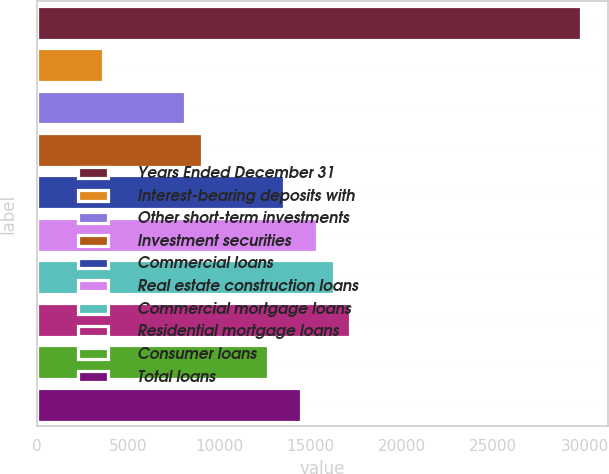Convert chart to OTSL. <chart><loc_0><loc_0><loc_500><loc_500><bar_chart><fcel>Years Ended December 31<fcel>Interest-bearing deposits with<fcel>Other short-term investments<fcel>Investment securities<fcel>Commercial loans<fcel>Real estate construction loans<fcel>Commercial mortgage loans<fcel>Residential mortgage loans<fcel>Consumer loans<fcel>Total loans<nl><fcel>29815.3<fcel>3614.08<fcel>8131.53<fcel>9035.02<fcel>13552.5<fcel>15359.5<fcel>16262.9<fcel>17166.4<fcel>12649<fcel>14456<nl></chart> 